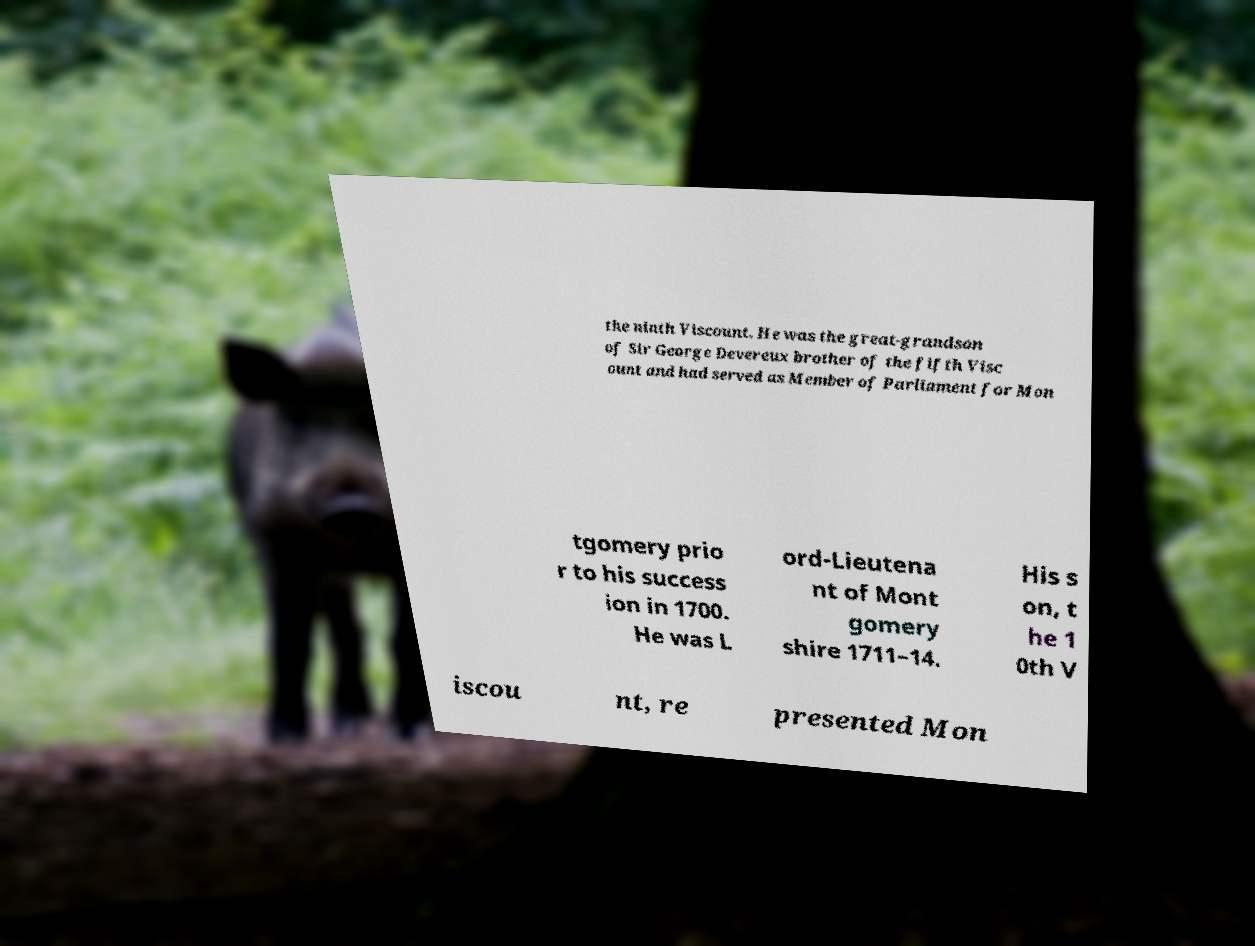I need the written content from this picture converted into text. Can you do that? the ninth Viscount. He was the great-grandson of Sir George Devereux brother of the fifth Visc ount and had served as Member of Parliament for Mon tgomery prio r to his success ion in 1700. He was L ord-Lieutena nt of Mont gomery shire 1711–14. His s on, t he 1 0th V iscou nt, re presented Mon 